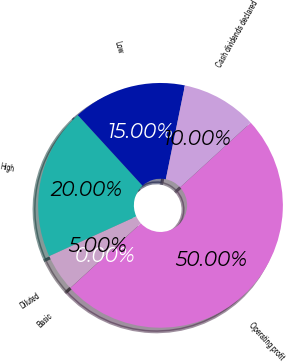<chart> <loc_0><loc_0><loc_500><loc_500><pie_chart><fcel>Operating profit<fcel>Basic<fcel>Diluted<fcel>High<fcel>Low<fcel>Cash dividends declared<nl><fcel>50.0%<fcel>0.0%<fcel>5.0%<fcel>20.0%<fcel>15.0%<fcel>10.0%<nl></chart> 